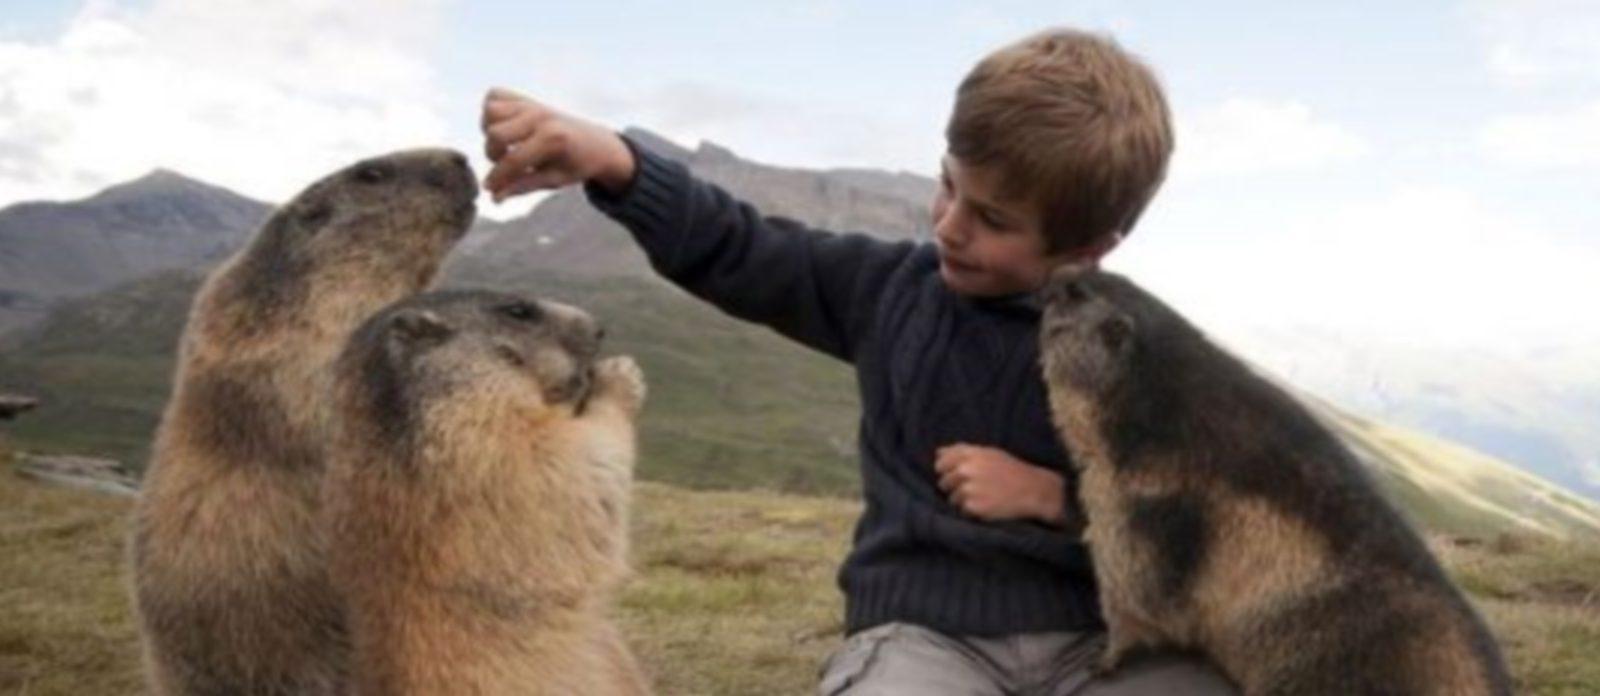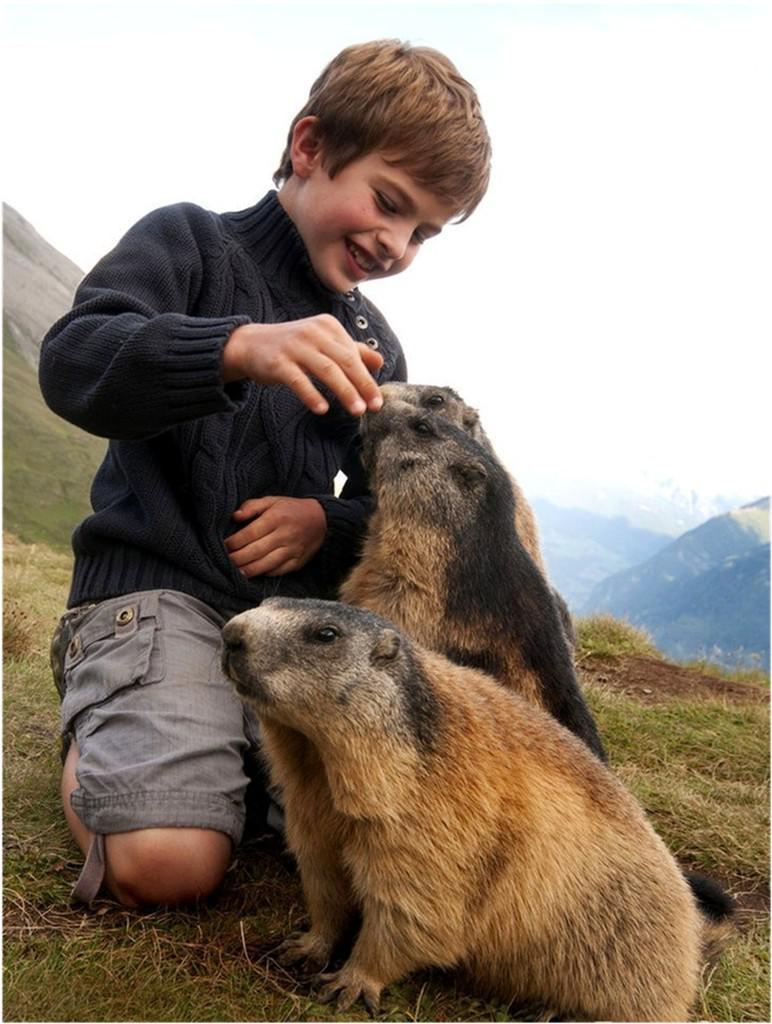The first image is the image on the left, the second image is the image on the right. Given the left and right images, does the statement "There are six marmots." hold true? Answer yes or no. Yes. The first image is the image on the left, the second image is the image on the right. For the images displayed, is the sentence "In the right image, there are at least three animals interacting with a young boy." factually correct? Answer yes or no. No. 